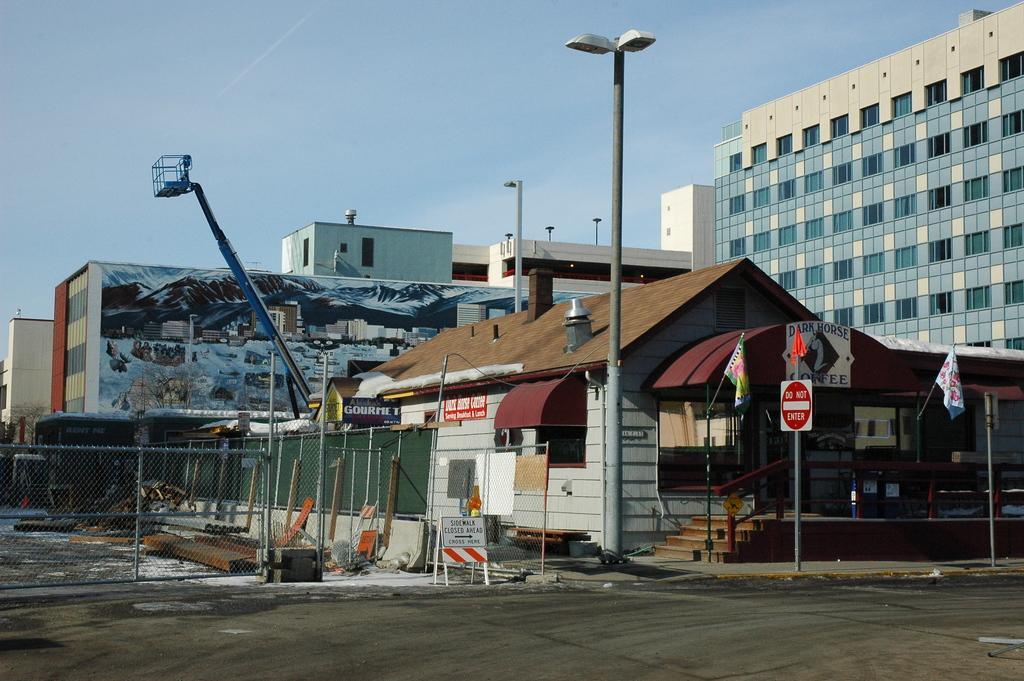How would you summarize this image in a sentence or two? In this picture there is a brown color shade and beside a fencing grill and lamp post. Behind there is a building with spray painted wall. On the right side of the image there is a white and blue color building. 